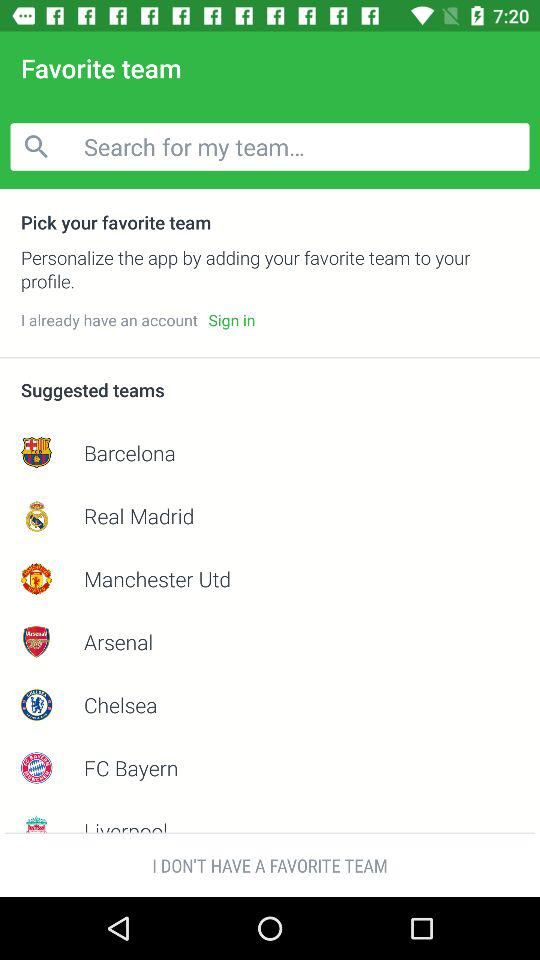How many teams playing in this?
When the provided information is insufficient, respond with <no answer>. <no answer> 